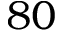<formula> <loc_0><loc_0><loc_500><loc_500>8 0</formula> 